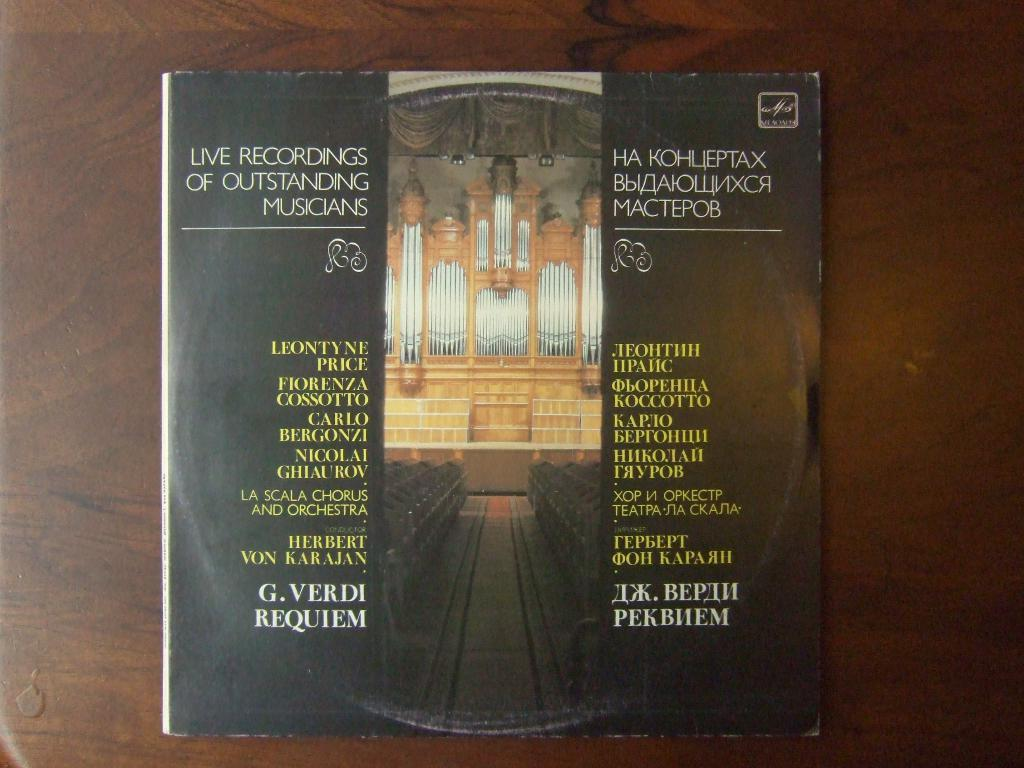<image>
Create a compact narrative representing the image presented. Live recordings of outstanding musicians by G. Verdi Requiem. 